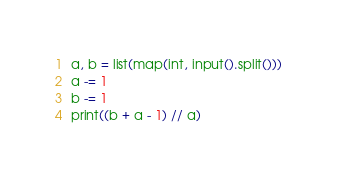Convert code to text. <code><loc_0><loc_0><loc_500><loc_500><_Python_>a, b = list(map(int, input().split()))
a -= 1
b -= 1
print((b + a - 1) // a)
</code> 